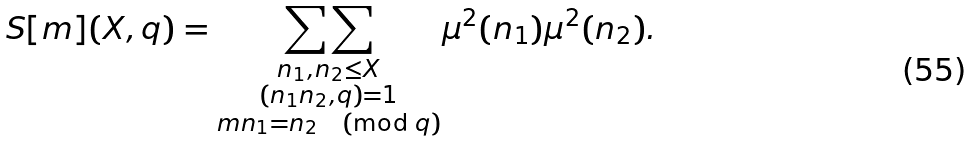Convert formula to latex. <formula><loc_0><loc_0><loc_500><loc_500>S [ m ] ( X , q ) = \underset { \substack { n _ { 1 } , n _ { 2 } \leq X \\ ( n _ { 1 } n _ { 2 } , q ) = 1 \\ m n _ { 1 } = n _ { 2 } \, \pmod { q } } } { \sum \sum } \mu ^ { 2 } ( n _ { 1 } ) \mu ^ { 2 } ( n _ { 2 } ) .</formula> 